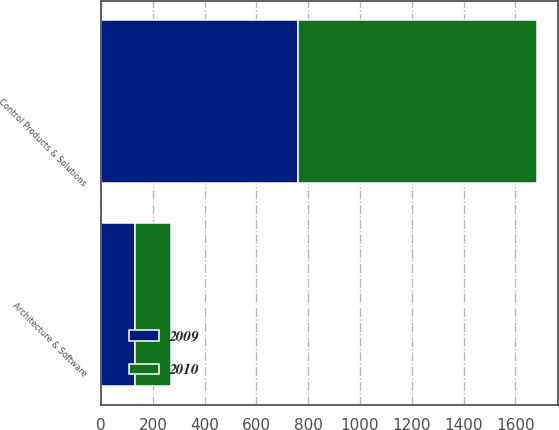Convert chart. <chart><loc_0><loc_0><loc_500><loc_500><stacked_bar_chart><ecel><fcel>Architecture & Software<fcel>Control Products & Solutions<nl><fcel>2010<fcel>140.6<fcel>921<nl><fcel>2009<fcel>130.6<fcel>761.3<nl></chart> 